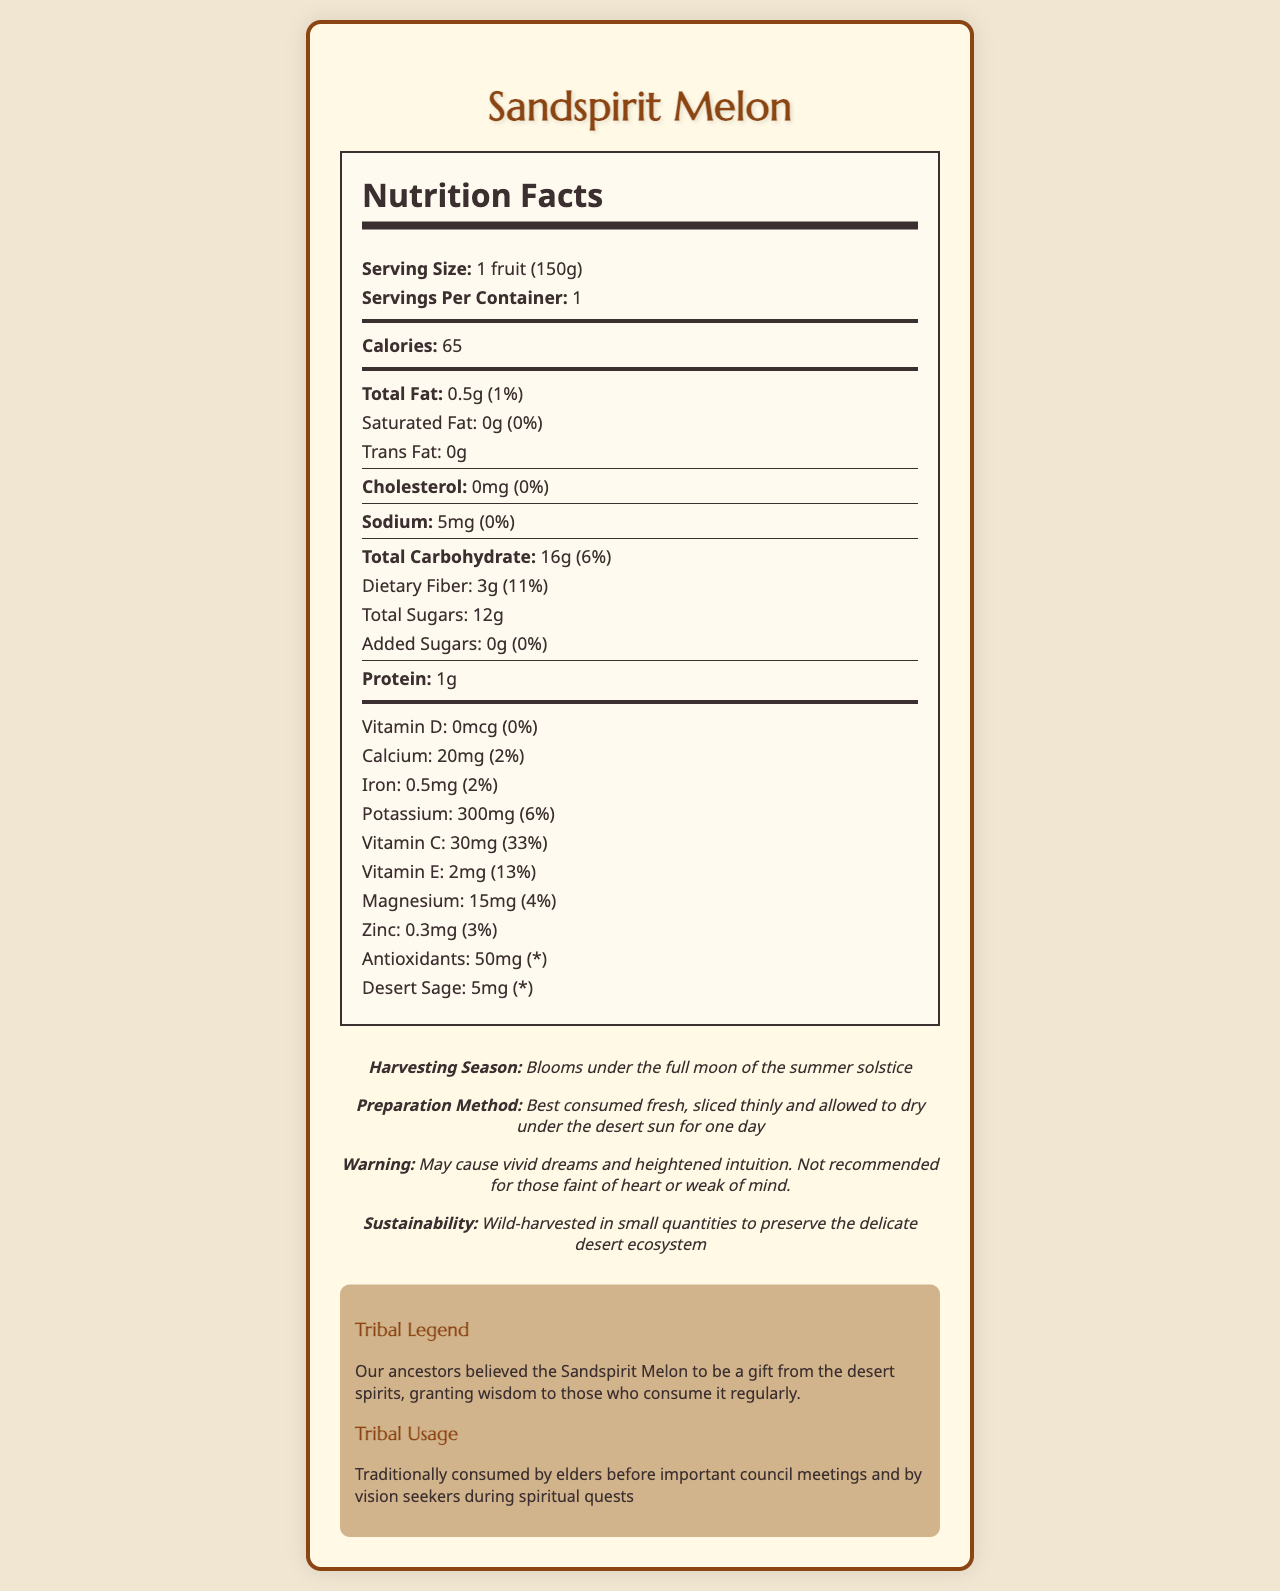what is the serving size of Sandspirit Melon? The document specifies that the serving size is "1 fruit (150g)".
Answer: 1 fruit (150g) how many calories are there per serving? The document lists the calories per serving as "65".
Answer: 65 what type of fat is completely absent in the Sandspirit Melon? The document shows that both Saturated Fat and Trans Fat amounts are "0g".
Answer: Saturated Fat and Trans Fat how much dietary fiber does the Sandspirit Melon contain? It is mentioned in the document that the dietary fiber amount is "3g".
Answer: 3g does the Sandspirit Melon contain any added sugars? The document lists added sugars as "0g".
Answer: No how much potassium is in one serving of Sandspirit Melon? A. 100mg B. 150mg C. 200mg D. 300mg The document states that potassium content is "300mg".
Answer: D which vitamin has the highest percent daily value in Sandspirit Melon? A. Vitamin D B. Vitamin C C. Vitamin E D. Magnesium Vitamin C has a daily value of 33%, which is the highest among the listed options.
Answer: B does the Sandspirit Melon have any protein content? The document indicates that the protein content is "1g".
Answer: Yes describe the traditional usage of Sandspirit Melon in the tribal community The document states that Sandspirit Melon is traditionally used by elders before important council meetings and by vision seekers during spiritual quests.
Answer: Traditionally consumed by elders before important council meetings and by vision seekers during spiritual quests is Sandspirit Melon recommended for those faint of heart or weak of mind? The warning statement specifies that it is not recommended for those faint of heart or weak of mind.
Answer: No When is the Sandspirit Melon harvested? The document mentions the harvesting season as "blooms under the full moon of the summer solstice".
Answer: Blooms under the full moon of the summer solstice what is the legend associated with the Sandspirit Melon? The document shares that the tribal legend considers the Sandspirit Melon as a gift from the desert spirits that grants wisdom to those who consume it regularly.
Answer: The Sandspirit Melon is believed to be a gift from the desert spirits, granting wisdom to those who consume it regularly. is the amount of antioxidants' percent daily value provided? The document lists the antioxidants' amount but marks the percent daily value with an asterisk (*), indicating it is not provided.
Answer: No how should the Sandspirit Melon be prepared? The document indicates the preparation method as consuming it fresh, sliced thinly, and drying under the desert sun for one day.
Answer: Best consumed fresh, sliced thinly and allowed to dry under the desert sun for one day what is the total carbohydrate content per serving? The document states that the total carbohydrate amount is "16g".
Answer: 16g what sustainability practice is followed for harvesting Sandspirit Melon? The document specifies the sustainability note as "wild-harvested in small quantities to preserve the delicate desert ecosystem".
Answer: Wild-harvested in small quantities to preserve the delicate desert ecosystem can the specific benefits of Desert Sage in the Sandspirit Melon be determined from the document? The document lists the amount of Desert Sage but does not elaborate on its specific benefits.
Answer: Not enough information summarize the main idea of the document The document combines nutritional information with cultural and traditional insights, offering a comprehensive overview of the Sandspirit Melon's significance and dietary content.
Answer: The document provides detailed nutrition facts of the Sandspirit Melon, including its serving size, nutrient content, and percent daily values for various vitamins and minerals. It also shares tribal legends, traditional usage, harvesting season, preparation methods, warnings, and sustainability practices related to the Sandspirit Melon. 